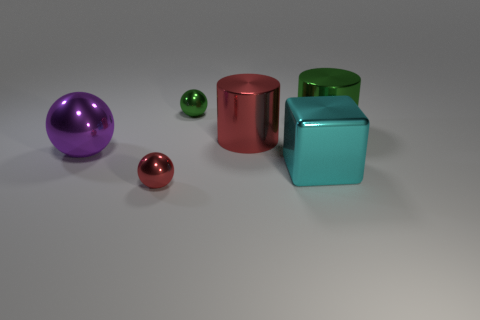What number of large metallic things are both left of the large green metal thing and behind the purple object?
Offer a very short reply. 1. Is the material of the large cyan object the same as the big red object?
Provide a short and direct response. Yes. The thing left of the small metallic thing in front of the metal cylinder that is on the left side of the cyan metallic block is what shape?
Give a very brief answer. Sphere. What material is the big object that is to the right of the large purple ball and left of the cube?
Provide a short and direct response. Metal. The metallic ball that is behind the large cylinder that is to the right of the red metal thing that is on the right side of the small red metallic thing is what color?
Provide a short and direct response. Green. What number of yellow things are either large metallic cylinders or shiny balls?
Make the answer very short. 0. How many other things are the same size as the green shiny cylinder?
Your answer should be very brief. 3. What number of small cyan cylinders are there?
Make the answer very short. 0. Are there any other things that are the same shape as the large cyan metal thing?
Offer a very short reply. No. Do the big cylinder that is to the left of the green cylinder and the small object behind the red metallic ball have the same material?
Make the answer very short. Yes. 